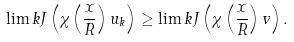Convert formula to latex. <formula><loc_0><loc_0><loc_500><loc_500>\lim k J \left ( \chi \left ( \frac { x } { R } \right ) u _ { k } \right ) \geq \lim k J \left ( \chi \left ( \frac { x } { R } \right ) v \right ) .</formula> 